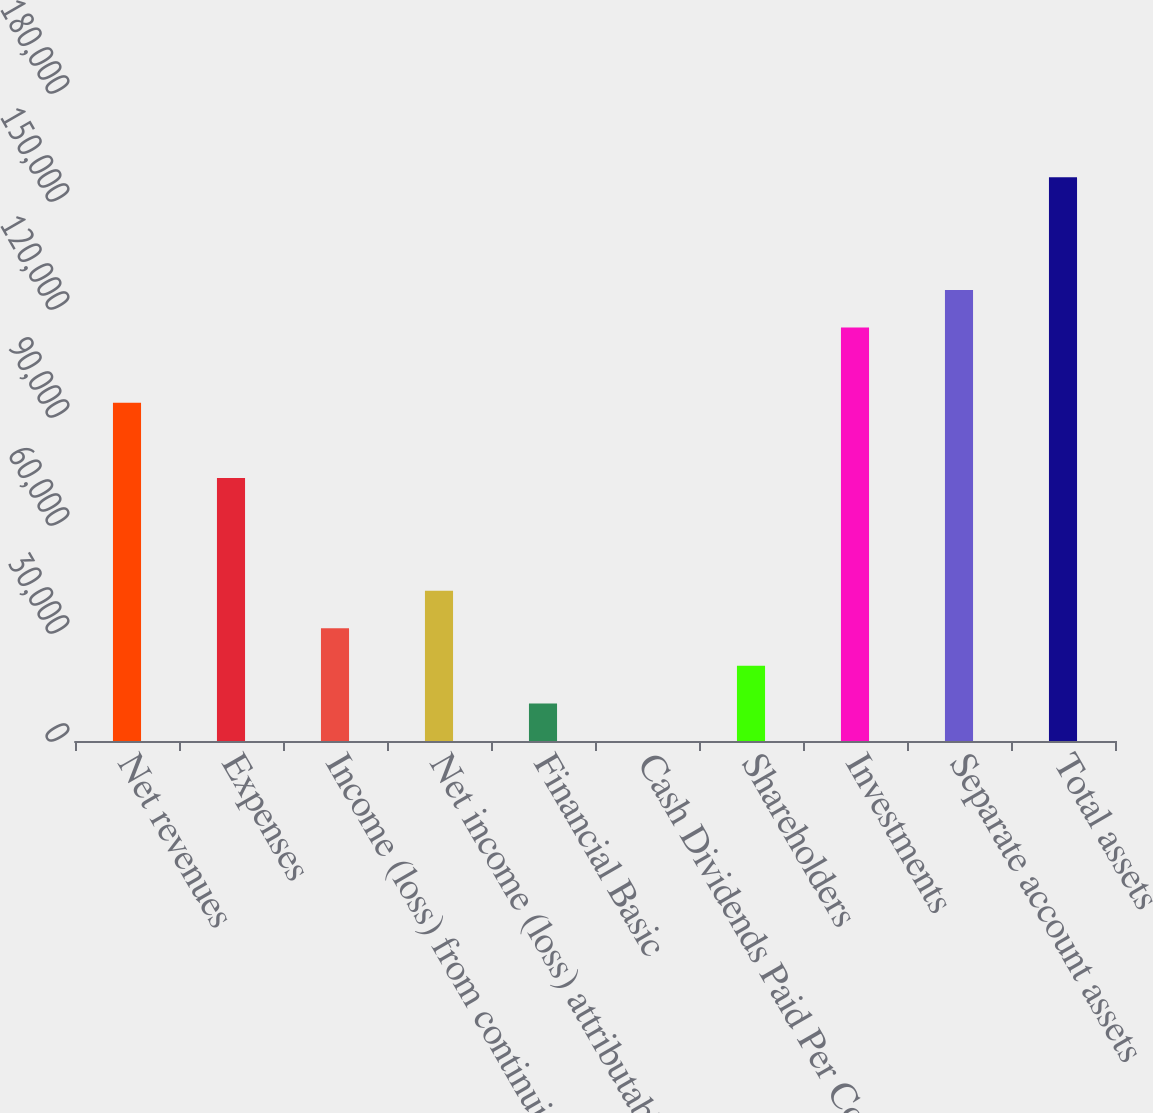<chart> <loc_0><loc_0><loc_500><loc_500><bar_chart><fcel>Net revenues<fcel>Expenses<fcel>Income (loss) from continuing<fcel>Net income (loss) attributable<fcel>Financial Basic<fcel>Cash Dividends Paid Per Common<fcel>Shareholders<fcel>Investments<fcel>Separate account assets<fcel>Total assets<nl><fcel>93952<fcel>73073.9<fcel>31317.6<fcel>41756.7<fcel>10439.5<fcel>0.44<fcel>20878.6<fcel>114830<fcel>125269<fcel>156586<nl></chart> 